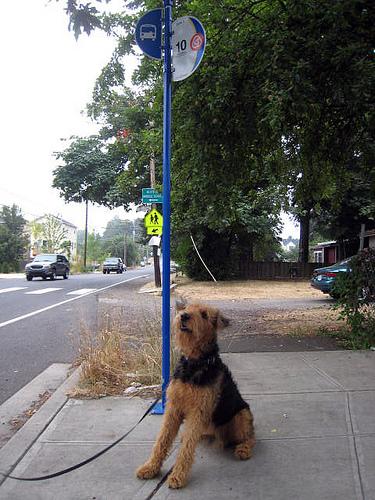Is the dog waiting for someone?
Answer briefly. Yes. Is this near a school?
Give a very brief answer. Yes. What kind of dog is this?
Be succinct. Mutt. 